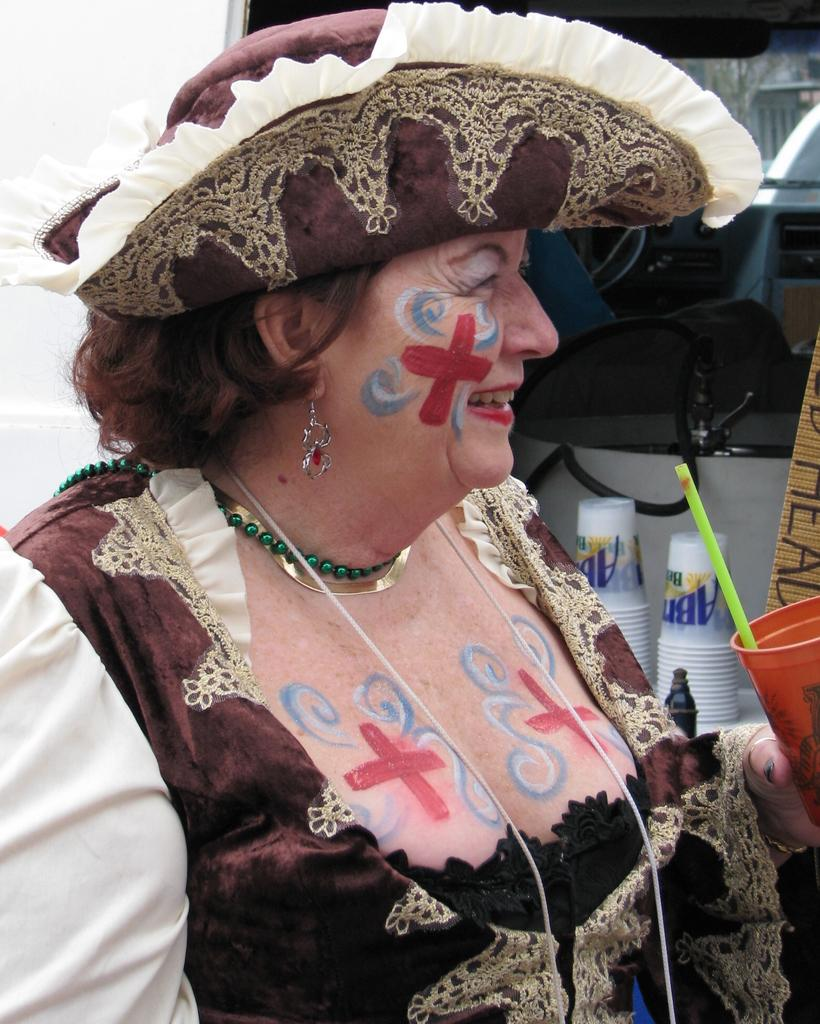Who is the main subject in the image? There is a woman in the center of the image. What is the woman wearing on her head? The woman is wearing a hat. What can be seen in the background of the image? There are glasses and a wall in the background of the image. What type of glue is the woman using in the image? There is no glue present in the image, and the woman is not using any glue. 